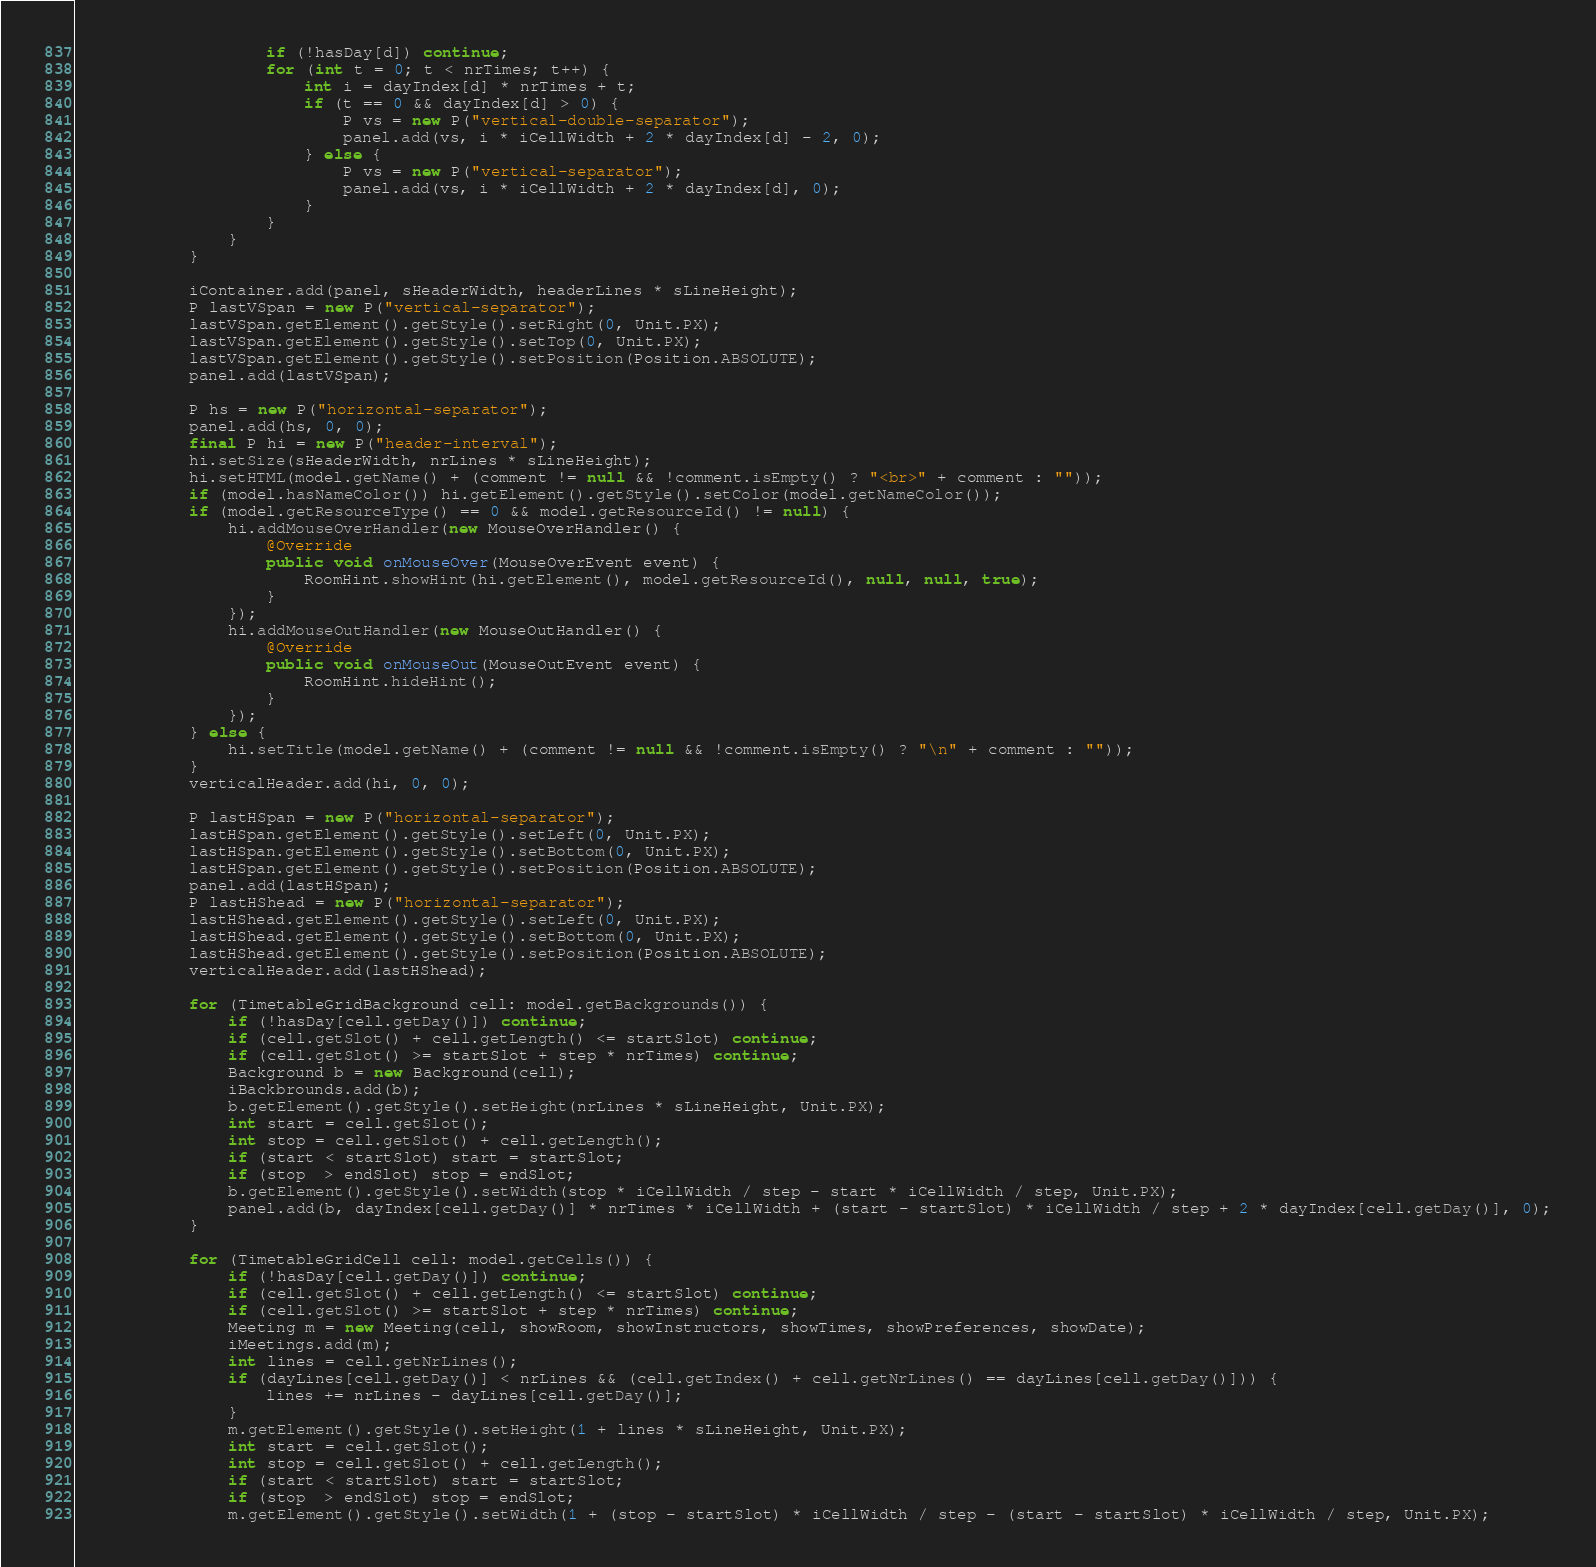Convert code to text. <code><loc_0><loc_0><loc_500><loc_500><_Java_>					if (!hasDay[d]) continue;
					for (int t = 0; t < nrTimes; t++) {
						int i = dayIndex[d] * nrTimes + t;
						if (t == 0 && dayIndex[d] > 0) {
							P vs = new P("vertical-double-separator");
							panel.add(vs, i * iCellWidth + 2 * dayIndex[d] - 2, 0);
						} else {
							P vs = new P("vertical-separator");
							panel.add(vs, i * iCellWidth + 2 * dayIndex[d], 0);
						}
					}
				}
			}
			
			iContainer.add(panel, sHeaderWidth, headerLines * sLineHeight);
			P lastVSpan = new P("vertical-separator");
			lastVSpan.getElement().getStyle().setRight(0, Unit.PX);
			lastVSpan.getElement().getStyle().setTop(0, Unit.PX);
			lastVSpan.getElement().getStyle().setPosition(Position.ABSOLUTE);
			panel.add(lastVSpan);
			
	        P hs = new P("horizontal-separator");
	        panel.add(hs, 0, 0);
	        final P hi = new P("header-interval");
	        hi.setSize(sHeaderWidth, nrLines * sLineHeight);
	        hi.setHTML(model.getName() + (comment != null && !comment.isEmpty() ? "<br>" + comment : ""));
	        if (model.hasNameColor()) hi.getElement().getStyle().setColor(model.getNameColor());
	        if (model.getResourceType() == 0 && model.getResourceId() != null) {
	        	hi.addMouseOverHandler(new MouseOverHandler() {
					@Override
					public void onMouseOver(MouseOverEvent event) {
						RoomHint.showHint(hi.getElement(), model.getResourceId(), null, null, true);
					}
				});
	        	hi.addMouseOutHandler(new MouseOutHandler() {
					@Override
					public void onMouseOut(MouseOutEvent event) {
						RoomHint.hideHint();
					}
				});
	        } else {
	        	hi.setTitle(model.getName() + (comment != null && !comment.isEmpty() ? "\n" + comment : ""));
	        }
	        verticalHeader.add(hi, 0, 0);
	        
	        P lastHSpan = new P("horizontal-separator");
			lastHSpan.getElement().getStyle().setLeft(0, Unit.PX);
			lastHSpan.getElement().getStyle().setBottom(0, Unit.PX);
			lastHSpan.getElement().getStyle().setPosition(Position.ABSOLUTE);
			panel.add(lastHSpan);
			P lastHShead = new P("horizontal-separator");
			lastHShead.getElement().getStyle().setLeft(0, Unit.PX);
			lastHShead.getElement().getStyle().setBottom(0, Unit.PX);
			lastHShead.getElement().getStyle().setPosition(Position.ABSOLUTE);
			verticalHeader.add(lastHShead);
			
			for (TimetableGridBackground cell: model.getBackgrounds()) {
	        	if (!hasDay[cell.getDay()]) continue;
	        	if (cell.getSlot() + cell.getLength() <= startSlot) continue;
	        	if (cell.getSlot() >= startSlot + step * nrTimes) continue;
	        	Background b = new Background(cell);
	        	iBackbrounds.add(b);
	        	b.getElement().getStyle().setHeight(nrLines * sLineHeight, Unit.PX);
		        int start = cell.getSlot();
		        int stop = cell.getSlot() + cell.getLength();
		        if (start < startSlot) start = startSlot;
		        if (stop  > endSlot) stop = endSlot;
		        b.getElement().getStyle().setWidth(stop * iCellWidth / step - start * iCellWidth / step, Unit.PX);
		        panel.add(b, dayIndex[cell.getDay()] * nrTimes * iCellWidth + (start - startSlot) * iCellWidth / step + 2 * dayIndex[cell.getDay()], 0);
			}
	        
	        for (TimetableGridCell cell: model.getCells()) {
	        	if (!hasDay[cell.getDay()]) continue;
	        	if (cell.getSlot() + cell.getLength() <= startSlot) continue;
	        	if (cell.getSlot() >= startSlot + step * nrTimes) continue;
	        	Meeting m = new Meeting(cell, showRoom, showInstructors, showTimes, showPreferences, showDate);
	        	iMeetings.add(m);
		        int lines = cell.getNrLines();
		        if (dayLines[cell.getDay()] < nrLines && (cell.getIndex() + cell.getNrLines() == dayLines[cell.getDay()])) {
		        	lines += nrLines - dayLines[cell.getDay()];
		        }
		        m.getElement().getStyle().setHeight(1 + lines * sLineHeight, Unit.PX);
		        int start = cell.getSlot();
		        int stop = cell.getSlot() + cell.getLength();
		        if (start < startSlot) start = startSlot;
		        if (stop  > endSlot) stop = endSlot;
		        m.getElement().getStyle().setWidth(1 + (stop - startSlot) * iCellWidth / step - (start - startSlot) * iCellWidth / step, Unit.PX);</code> 